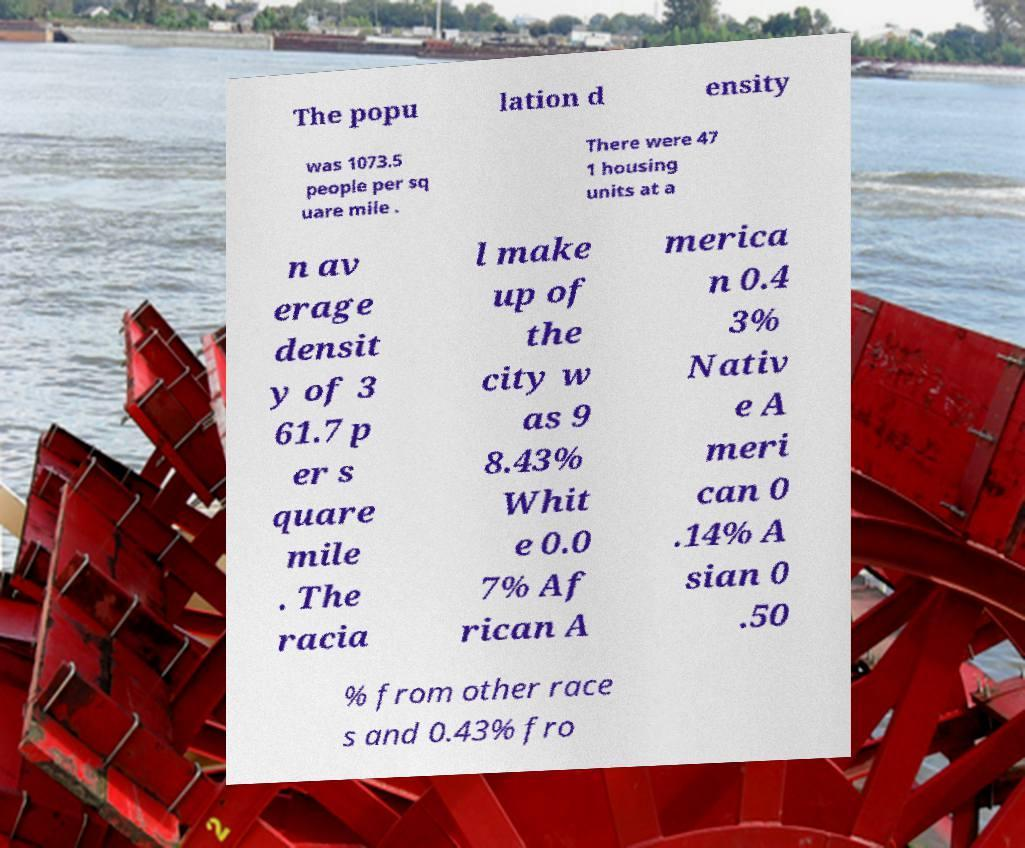Could you assist in decoding the text presented in this image and type it out clearly? The popu lation d ensity was 1073.5 people per sq uare mile . There were 47 1 housing units at a n av erage densit y of 3 61.7 p er s quare mile . The racia l make up of the city w as 9 8.43% Whit e 0.0 7% Af rican A merica n 0.4 3% Nativ e A meri can 0 .14% A sian 0 .50 % from other race s and 0.43% fro 